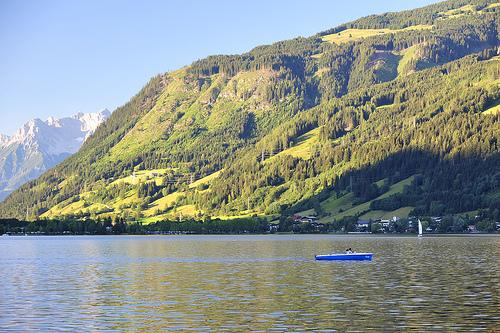Give the position and description of the trees in the image. The trees are located to the right and left of the image and can be seen on the mountain and near the water's edge. Where can snow be observed in the image and in what context? Snow can be seen on the top of the mountain in the background of the image. Provide a brief description of any building structures in the image. There are houses located along the water's edge and one house surrounded by trees can be observed as well. Identify the natural structure seen behind the houses in the image. There is a green hill located behind the houses in the image. Mention two colors seen predominantly in the sky and describe its appearance. The sky has shades of blue and white, where the blue represents the sky's background color, and the white indicates the presence of clouds. What is the state of the water and mention one notable feature about it. The water is calm, and it has noticeable ripples on its surface. Briefly narrate any recreational activity observed in the picture. There are people enjoying a leisurely ride in a blue boat on the water. What is the color of the boat and what is it doing in the image? The color of the boat is blue, and it is floating in the water. Point out any instance of shadows in the image and where they can be seen. Shadows can be seen on the mountain in the background, indicating a strong source of light. Identify the type and color of the sail on the boat. The sail on the boat is white and belongs to a sailboat. Can you find the hot air balloons flying over the mountains? No, it's not mentioned in the image. 